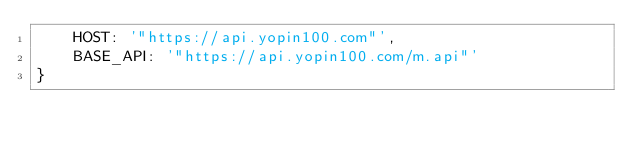Convert code to text. <code><loc_0><loc_0><loc_500><loc_500><_JavaScript_>    HOST: '"https://api.yopin100.com"',
  	BASE_API: '"https://api.yopin100.com/m.api"'
}
</code> 